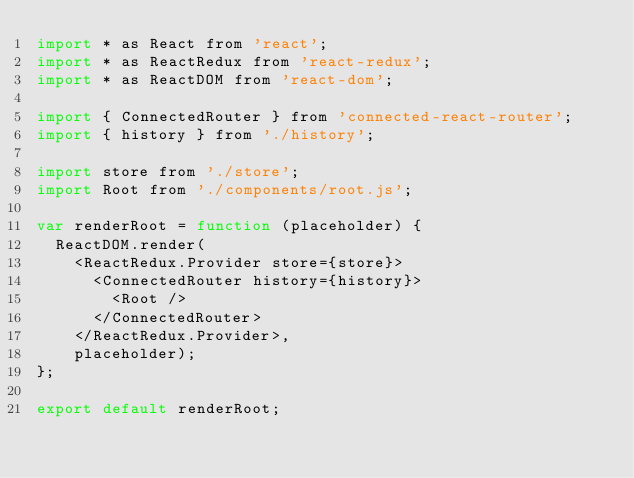<code> <loc_0><loc_0><loc_500><loc_500><_JavaScript_>import * as React from 'react';
import * as ReactRedux from 'react-redux';
import * as ReactDOM from 'react-dom';

import { ConnectedRouter } from 'connected-react-router';
import { history } from './history';

import store from './store';
import Root from './components/root.js';

var renderRoot = function (placeholder) {
  ReactDOM.render(
    <ReactRedux.Provider store={store}>
      <ConnectedRouter history={history}>
        <Root />
      </ConnectedRouter>
    </ReactRedux.Provider>,
    placeholder);
};

export default renderRoot;</code> 